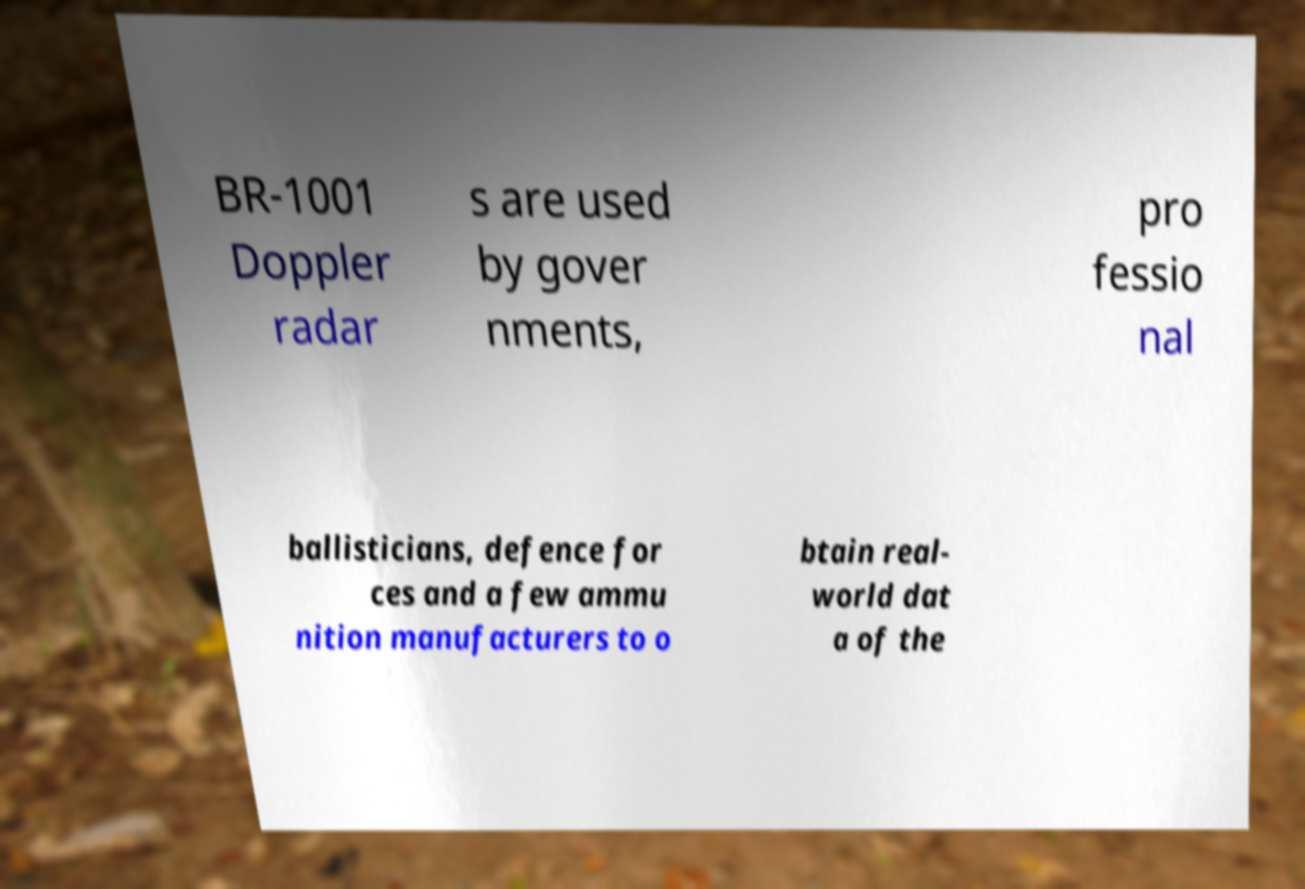Can you accurately transcribe the text from the provided image for me? BR-1001 Doppler radar s are used by gover nments, pro fessio nal ballisticians, defence for ces and a few ammu nition manufacturers to o btain real- world dat a of the 